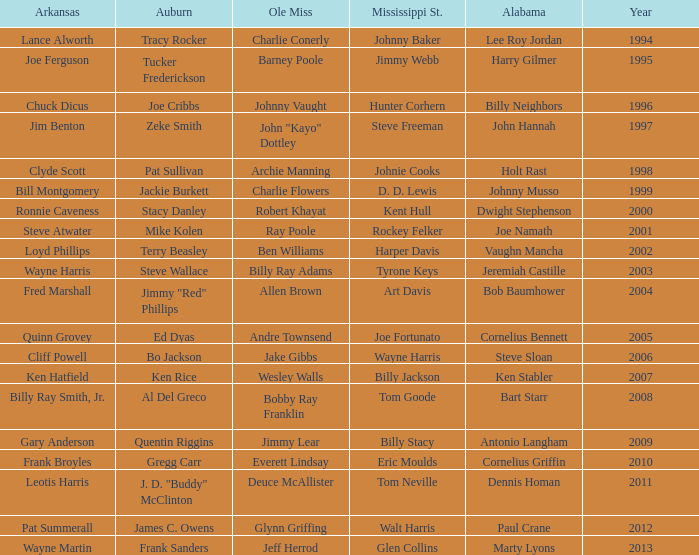Who was the player associated with Ole Miss in years after 2008 with a Mississippi St. name of Eric Moulds? Everett Lindsay. 